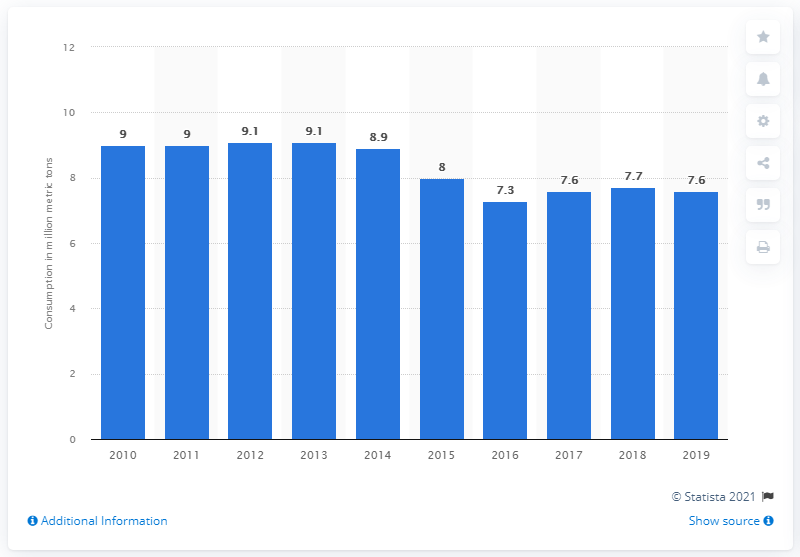Identify some key points in this picture. In 2019, the estimated amount of processed plastics consumed in Brazil was approximately 7.6 million metric tons. 